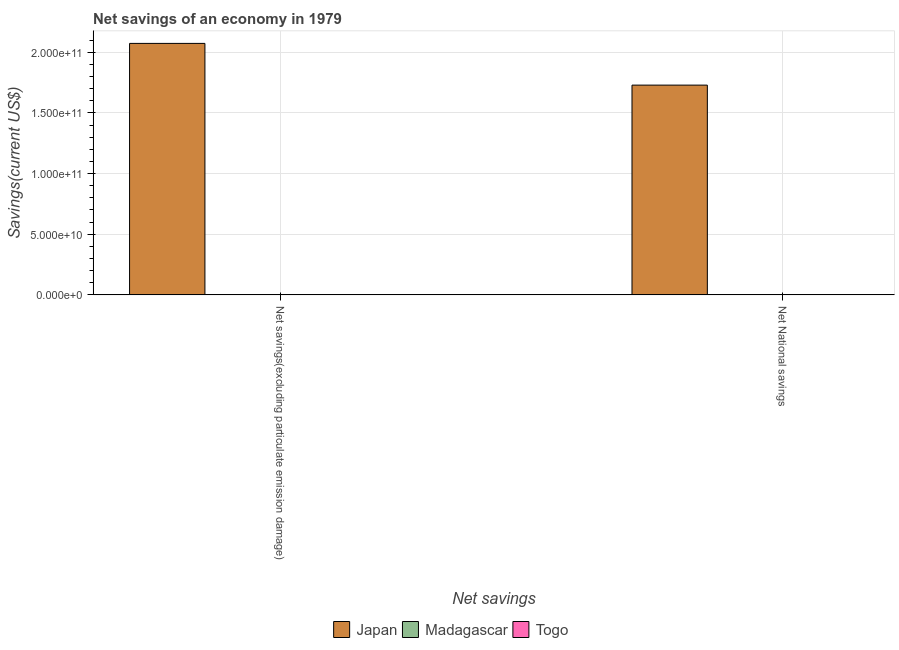Are the number of bars per tick equal to the number of legend labels?
Your response must be concise. No. How many bars are there on the 1st tick from the right?
Ensure brevity in your answer.  2. What is the label of the 1st group of bars from the left?
Your response must be concise. Net savings(excluding particulate emission damage). What is the net savings(excluding particulate emission damage) in Madagascar?
Provide a succinct answer. 0. Across all countries, what is the maximum net savings(excluding particulate emission damage)?
Offer a very short reply. 2.07e+11. Across all countries, what is the minimum net savings(excluding particulate emission damage)?
Your answer should be compact. 0. What is the total net national savings in the graph?
Make the answer very short. 1.73e+11. What is the difference between the net savings(excluding particulate emission damage) in Togo and that in Japan?
Keep it short and to the point. -2.07e+11. What is the difference between the net savings(excluding particulate emission damage) in Madagascar and the net national savings in Japan?
Provide a succinct answer. -1.73e+11. What is the average net national savings per country?
Ensure brevity in your answer.  5.77e+1. What is the difference between the net savings(excluding particulate emission damage) and net national savings in Togo?
Make the answer very short. -1.44e+07. What is the ratio of the net savings(excluding particulate emission damage) in Japan to that in Togo?
Provide a short and direct response. 1108.97. Is the net savings(excluding particulate emission damage) in Togo less than that in Japan?
Give a very brief answer. Yes. In how many countries, is the net national savings greater than the average net national savings taken over all countries?
Give a very brief answer. 1. Are all the bars in the graph horizontal?
Give a very brief answer. No. What is the difference between two consecutive major ticks on the Y-axis?
Offer a very short reply. 5.00e+1. What is the title of the graph?
Provide a short and direct response. Net savings of an economy in 1979. What is the label or title of the X-axis?
Ensure brevity in your answer.  Net savings. What is the label or title of the Y-axis?
Offer a very short reply. Savings(current US$). What is the Savings(current US$) of Japan in Net savings(excluding particulate emission damage)?
Make the answer very short. 2.07e+11. What is the Savings(current US$) in Togo in Net savings(excluding particulate emission damage)?
Make the answer very short. 1.87e+08. What is the Savings(current US$) of Japan in Net National savings?
Your response must be concise. 1.73e+11. What is the Savings(current US$) of Madagascar in Net National savings?
Your answer should be very brief. 0. What is the Savings(current US$) in Togo in Net National savings?
Offer a very short reply. 2.01e+08. Across all Net savings, what is the maximum Savings(current US$) of Japan?
Provide a short and direct response. 2.07e+11. Across all Net savings, what is the maximum Savings(current US$) of Togo?
Make the answer very short. 2.01e+08. Across all Net savings, what is the minimum Savings(current US$) of Japan?
Provide a succinct answer. 1.73e+11. Across all Net savings, what is the minimum Savings(current US$) of Togo?
Ensure brevity in your answer.  1.87e+08. What is the total Savings(current US$) of Japan in the graph?
Offer a very short reply. 3.80e+11. What is the total Savings(current US$) in Madagascar in the graph?
Keep it short and to the point. 0. What is the total Savings(current US$) in Togo in the graph?
Provide a short and direct response. 3.88e+08. What is the difference between the Savings(current US$) of Japan in Net savings(excluding particulate emission damage) and that in Net National savings?
Your response must be concise. 3.44e+1. What is the difference between the Savings(current US$) of Togo in Net savings(excluding particulate emission damage) and that in Net National savings?
Offer a terse response. -1.44e+07. What is the difference between the Savings(current US$) in Japan in Net savings(excluding particulate emission damage) and the Savings(current US$) in Togo in Net National savings?
Your response must be concise. 2.07e+11. What is the average Savings(current US$) of Japan per Net savings?
Offer a terse response. 1.90e+11. What is the average Savings(current US$) of Togo per Net savings?
Ensure brevity in your answer.  1.94e+08. What is the difference between the Savings(current US$) of Japan and Savings(current US$) of Togo in Net savings(excluding particulate emission damage)?
Offer a very short reply. 2.07e+11. What is the difference between the Savings(current US$) in Japan and Savings(current US$) in Togo in Net National savings?
Your answer should be compact. 1.73e+11. What is the ratio of the Savings(current US$) in Japan in Net savings(excluding particulate emission damage) to that in Net National savings?
Provide a short and direct response. 1.2. What is the ratio of the Savings(current US$) of Togo in Net savings(excluding particulate emission damage) to that in Net National savings?
Your answer should be compact. 0.93. What is the difference between the highest and the second highest Savings(current US$) in Japan?
Provide a short and direct response. 3.44e+1. What is the difference between the highest and the second highest Savings(current US$) of Togo?
Provide a succinct answer. 1.44e+07. What is the difference between the highest and the lowest Savings(current US$) of Japan?
Provide a succinct answer. 3.44e+1. What is the difference between the highest and the lowest Savings(current US$) in Togo?
Make the answer very short. 1.44e+07. 